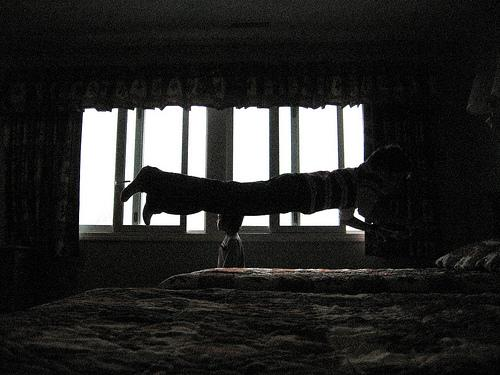Question: when was the picture taken?
Choices:
A. As boy dived on bed.
B. When the ball was hit.
C. As a touchdown was being completed.
D. As he scored his final points in basketball.
Answer with the letter. Answer: A Question: what design is on the shirt of the boy who is above the bed?
Choices:
A. Striped.
B. Dots.
C. Zebra pattern.
D. Small trucks.
Answer with the letter. Answer: A Question: who is looking out the window?
Choices:
A. Jack.
B. The mother.
C. A little boy.
D. The father.
Answer with the letter. Answer: C 